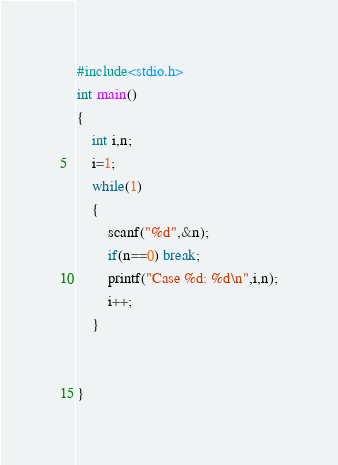Convert code to text. <code><loc_0><loc_0><loc_500><loc_500><_C_>
#include<stdio.h>
int main()
{
    int i,n;
    i=1;
    while(1)
    {
        scanf("%d",&n);
        if(n==0) break;
        printf("Case %d: %d\n",i,n);
        i++;
    }


}

</code> 